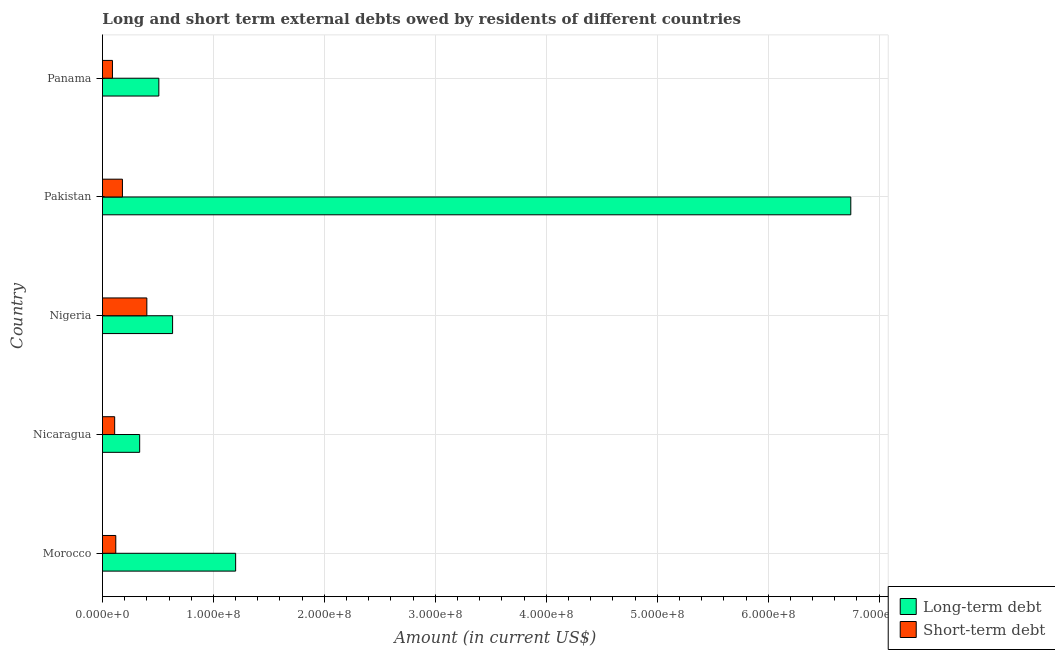How many groups of bars are there?
Provide a short and direct response. 5. Are the number of bars per tick equal to the number of legend labels?
Provide a succinct answer. Yes. What is the label of the 3rd group of bars from the top?
Make the answer very short. Nigeria. What is the long-term debts owed by residents in Panama?
Your response must be concise. 5.08e+07. Across all countries, what is the maximum short-term debts owed by residents?
Offer a very short reply. 4.00e+07. Across all countries, what is the minimum short-term debts owed by residents?
Provide a short and direct response. 9.00e+06. In which country was the long-term debts owed by residents maximum?
Provide a succinct answer. Pakistan. In which country was the short-term debts owed by residents minimum?
Ensure brevity in your answer.  Panama. What is the total long-term debts owed by residents in the graph?
Provide a succinct answer. 9.42e+08. What is the difference between the short-term debts owed by residents in Nicaragua and that in Pakistan?
Provide a short and direct response. -7.00e+06. What is the difference between the long-term debts owed by residents in Pakistan and the short-term debts owed by residents in Morocco?
Your response must be concise. 6.62e+08. What is the average long-term debts owed by residents per country?
Give a very brief answer. 1.88e+08. What is the difference between the long-term debts owed by residents and short-term debts owed by residents in Panama?
Offer a terse response. 4.18e+07. In how many countries, is the long-term debts owed by residents greater than 660000000 US$?
Offer a terse response. 1. What is the ratio of the short-term debts owed by residents in Nigeria to that in Panama?
Make the answer very short. 4.44. What is the difference between the highest and the second highest short-term debts owed by residents?
Give a very brief answer. 2.20e+07. What is the difference between the highest and the lowest long-term debts owed by residents?
Your answer should be very brief. 6.41e+08. What does the 2nd bar from the top in Pakistan represents?
Your answer should be very brief. Long-term debt. What does the 2nd bar from the bottom in Pakistan represents?
Provide a short and direct response. Short-term debt. How many bars are there?
Your answer should be compact. 10. Are all the bars in the graph horizontal?
Your response must be concise. Yes. What is the difference between two consecutive major ticks on the X-axis?
Give a very brief answer. 1.00e+08. Does the graph contain any zero values?
Make the answer very short. No. Where does the legend appear in the graph?
Your answer should be compact. Bottom right. How many legend labels are there?
Keep it short and to the point. 2. What is the title of the graph?
Your response must be concise. Long and short term external debts owed by residents of different countries. What is the Amount (in current US$) of Long-term debt in Morocco?
Offer a very short reply. 1.20e+08. What is the Amount (in current US$) in Short-term debt in Morocco?
Your answer should be compact. 1.20e+07. What is the Amount (in current US$) of Long-term debt in Nicaragua?
Keep it short and to the point. 3.35e+07. What is the Amount (in current US$) of Short-term debt in Nicaragua?
Offer a very short reply. 1.10e+07. What is the Amount (in current US$) of Long-term debt in Nigeria?
Your response must be concise. 6.32e+07. What is the Amount (in current US$) of Short-term debt in Nigeria?
Your response must be concise. 4.00e+07. What is the Amount (in current US$) in Long-term debt in Pakistan?
Provide a succinct answer. 6.74e+08. What is the Amount (in current US$) in Short-term debt in Pakistan?
Give a very brief answer. 1.80e+07. What is the Amount (in current US$) in Long-term debt in Panama?
Ensure brevity in your answer.  5.08e+07. What is the Amount (in current US$) in Short-term debt in Panama?
Make the answer very short. 9.00e+06. Across all countries, what is the maximum Amount (in current US$) of Long-term debt?
Your answer should be compact. 6.74e+08. Across all countries, what is the maximum Amount (in current US$) of Short-term debt?
Your response must be concise. 4.00e+07. Across all countries, what is the minimum Amount (in current US$) in Long-term debt?
Provide a succinct answer. 3.35e+07. Across all countries, what is the minimum Amount (in current US$) of Short-term debt?
Provide a succinct answer. 9.00e+06. What is the total Amount (in current US$) in Long-term debt in the graph?
Your response must be concise. 9.42e+08. What is the total Amount (in current US$) of Short-term debt in the graph?
Your response must be concise. 9.00e+07. What is the difference between the Amount (in current US$) in Long-term debt in Morocco and that in Nicaragua?
Ensure brevity in your answer.  8.65e+07. What is the difference between the Amount (in current US$) of Long-term debt in Morocco and that in Nigeria?
Offer a terse response. 5.68e+07. What is the difference between the Amount (in current US$) in Short-term debt in Morocco and that in Nigeria?
Offer a very short reply. -2.80e+07. What is the difference between the Amount (in current US$) in Long-term debt in Morocco and that in Pakistan?
Your response must be concise. -5.54e+08. What is the difference between the Amount (in current US$) of Short-term debt in Morocco and that in Pakistan?
Ensure brevity in your answer.  -6.00e+06. What is the difference between the Amount (in current US$) in Long-term debt in Morocco and that in Panama?
Make the answer very short. 6.92e+07. What is the difference between the Amount (in current US$) of Short-term debt in Morocco and that in Panama?
Offer a terse response. 3.00e+06. What is the difference between the Amount (in current US$) of Long-term debt in Nicaragua and that in Nigeria?
Provide a succinct answer. -2.97e+07. What is the difference between the Amount (in current US$) in Short-term debt in Nicaragua and that in Nigeria?
Give a very brief answer. -2.90e+07. What is the difference between the Amount (in current US$) of Long-term debt in Nicaragua and that in Pakistan?
Keep it short and to the point. -6.41e+08. What is the difference between the Amount (in current US$) in Short-term debt in Nicaragua and that in Pakistan?
Your answer should be compact. -7.00e+06. What is the difference between the Amount (in current US$) in Long-term debt in Nicaragua and that in Panama?
Ensure brevity in your answer.  -1.73e+07. What is the difference between the Amount (in current US$) of Short-term debt in Nicaragua and that in Panama?
Ensure brevity in your answer.  2.00e+06. What is the difference between the Amount (in current US$) of Long-term debt in Nigeria and that in Pakistan?
Offer a very short reply. -6.11e+08. What is the difference between the Amount (in current US$) in Short-term debt in Nigeria and that in Pakistan?
Give a very brief answer. 2.20e+07. What is the difference between the Amount (in current US$) of Long-term debt in Nigeria and that in Panama?
Give a very brief answer. 1.24e+07. What is the difference between the Amount (in current US$) in Short-term debt in Nigeria and that in Panama?
Your answer should be very brief. 3.10e+07. What is the difference between the Amount (in current US$) of Long-term debt in Pakistan and that in Panama?
Your answer should be very brief. 6.24e+08. What is the difference between the Amount (in current US$) of Short-term debt in Pakistan and that in Panama?
Keep it short and to the point. 9.00e+06. What is the difference between the Amount (in current US$) of Long-term debt in Morocco and the Amount (in current US$) of Short-term debt in Nicaragua?
Provide a succinct answer. 1.09e+08. What is the difference between the Amount (in current US$) of Long-term debt in Morocco and the Amount (in current US$) of Short-term debt in Nigeria?
Ensure brevity in your answer.  8.00e+07. What is the difference between the Amount (in current US$) in Long-term debt in Morocco and the Amount (in current US$) in Short-term debt in Pakistan?
Provide a succinct answer. 1.02e+08. What is the difference between the Amount (in current US$) of Long-term debt in Morocco and the Amount (in current US$) of Short-term debt in Panama?
Offer a terse response. 1.11e+08. What is the difference between the Amount (in current US$) of Long-term debt in Nicaragua and the Amount (in current US$) of Short-term debt in Nigeria?
Provide a short and direct response. -6.47e+06. What is the difference between the Amount (in current US$) in Long-term debt in Nicaragua and the Amount (in current US$) in Short-term debt in Pakistan?
Offer a very short reply. 1.55e+07. What is the difference between the Amount (in current US$) in Long-term debt in Nicaragua and the Amount (in current US$) in Short-term debt in Panama?
Your answer should be very brief. 2.45e+07. What is the difference between the Amount (in current US$) in Long-term debt in Nigeria and the Amount (in current US$) in Short-term debt in Pakistan?
Provide a succinct answer. 4.52e+07. What is the difference between the Amount (in current US$) in Long-term debt in Nigeria and the Amount (in current US$) in Short-term debt in Panama?
Provide a succinct answer. 5.42e+07. What is the difference between the Amount (in current US$) in Long-term debt in Pakistan and the Amount (in current US$) in Short-term debt in Panama?
Give a very brief answer. 6.65e+08. What is the average Amount (in current US$) in Long-term debt per country?
Make the answer very short. 1.88e+08. What is the average Amount (in current US$) of Short-term debt per country?
Offer a terse response. 1.80e+07. What is the difference between the Amount (in current US$) of Long-term debt and Amount (in current US$) of Short-term debt in Morocco?
Offer a terse response. 1.08e+08. What is the difference between the Amount (in current US$) in Long-term debt and Amount (in current US$) in Short-term debt in Nicaragua?
Your response must be concise. 2.25e+07. What is the difference between the Amount (in current US$) in Long-term debt and Amount (in current US$) in Short-term debt in Nigeria?
Make the answer very short. 2.32e+07. What is the difference between the Amount (in current US$) in Long-term debt and Amount (in current US$) in Short-term debt in Pakistan?
Provide a succinct answer. 6.56e+08. What is the difference between the Amount (in current US$) in Long-term debt and Amount (in current US$) in Short-term debt in Panama?
Your answer should be compact. 4.18e+07. What is the ratio of the Amount (in current US$) of Long-term debt in Morocco to that in Nicaragua?
Provide a short and direct response. 3.58. What is the ratio of the Amount (in current US$) of Long-term debt in Morocco to that in Nigeria?
Provide a short and direct response. 1.9. What is the ratio of the Amount (in current US$) in Short-term debt in Morocco to that in Nigeria?
Provide a short and direct response. 0.3. What is the ratio of the Amount (in current US$) in Long-term debt in Morocco to that in Pakistan?
Make the answer very short. 0.18. What is the ratio of the Amount (in current US$) of Long-term debt in Morocco to that in Panama?
Your answer should be very brief. 2.36. What is the ratio of the Amount (in current US$) of Short-term debt in Morocco to that in Panama?
Give a very brief answer. 1.33. What is the ratio of the Amount (in current US$) in Long-term debt in Nicaragua to that in Nigeria?
Ensure brevity in your answer.  0.53. What is the ratio of the Amount (in current US$) of Short-term debt in Nicaragua to that in Nigeria?
Your answer should be compact. 0.28. What is the ratio of the Amount (in current US$) in Long-term debt in Nicaragua to that in Pakistan?
Ensure brevity in your answer.  0.05. What is the ratio of the Amount (in current US$) in Short-term debt in Nicaragua to that in Pakistan?
Offer a terse response. 0.61. What is the ratio of the Amount (in current US$) of Long-term debt in Nicaragua to that in Panama?
Provide a short and direct response. 0.66. What is the ratio of the Amount (in current US$) of Short-term debt in Nicaragua to that in Panama?
Ensure brevity in your answer.  1.22. What is the ratio of the Amount (in current US$) in Long-term debt in Nigeria to that in Pakistan?
Keep it short and to the point. 0.09. What is the ratio of the Amount (in current US$) in Short-term debt in Nigeria to that in Pakistan?
Make the answer very short. 2.22. What is the ratio of the Amount (in current US$) in Long-term debt in Nigeria to that in Panama?
Make the answer very short. 1.24. What is the ratio of the Amount (in current US$) of Short-term debt in Nigeria to that in Panama?
Your answer should be very brief. 4.44. What is the ratio of the Amount (in current US$) of Long-term debt in Pakistan to that in Panama?
Make the answer very short. 13.27. What is the ratio of the Amount (in current US$) of Short-term debt in Pakistan to that in Panama?
Offer a very short reply. 2. What is the difference between the highest and the second highest Amount (in current US$) in Long-term debt?
Ensure brevity in your answer.  5.54e+08. What is the difference between the highest and the second highest Amount (in current US$) of Short-term debt?
Your response must be concise. 2.20e+07. What is the difference between the highest and the lowest Amount (in current US$) of Long-term debt?
Make the answer very short. 6.41e+08. What is the difference between the highest and the lowest Amount (in current US$) of Short-term debt?
Ensure brevity in your answer.  3.10e+07. 